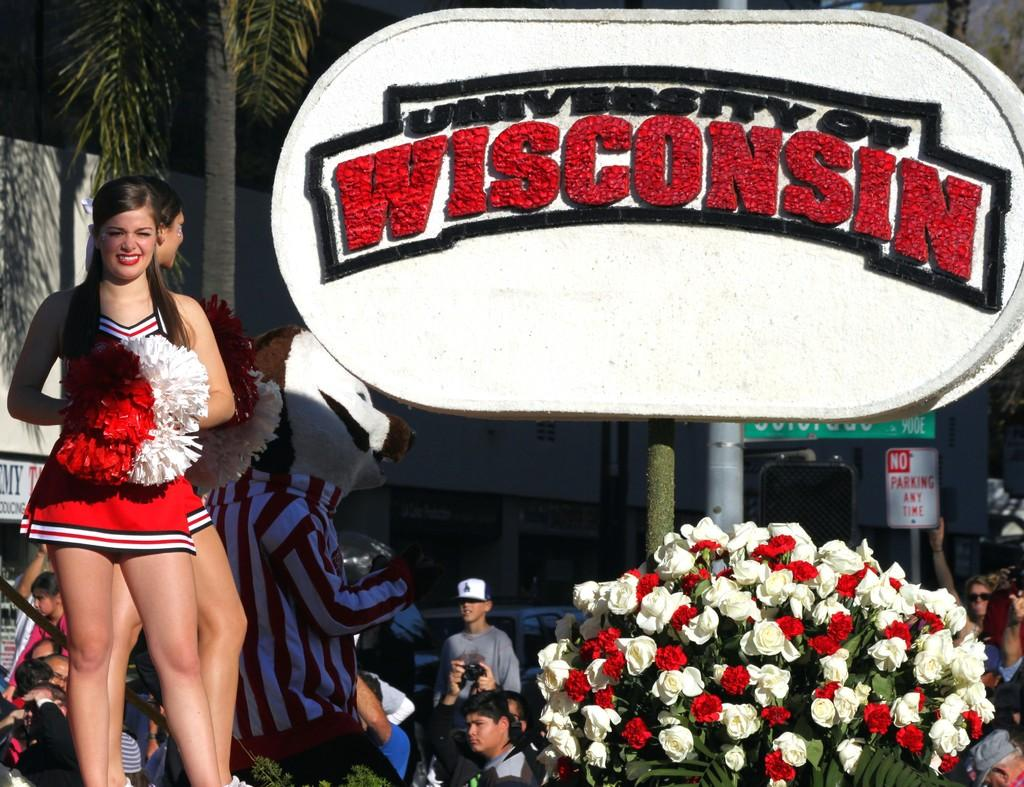<image>
Write a terse but informative summary of the picture. A cheerleader stands in front of a sign saying University of Wisconsin. 